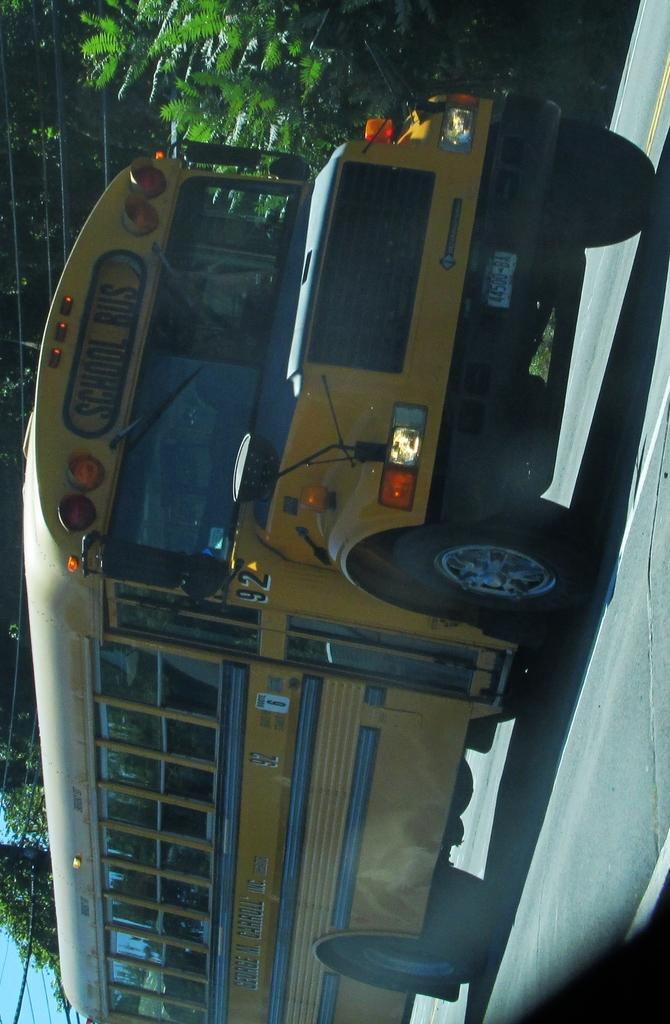What type of vehicle is on the road in the image? There is a school bus on the road in the image. What can be seen in the background of the image? There are trees visible in the image. What else is present in the image besides the school bus and trees? There are wires in the image. What is visible at the top of the image? The sky is visible at the top of the image. What type of prison can be seen in the image? There is no prison present in the image. Can you tell me how many wrists are visible in the image? There are no wrists visible in the image. 